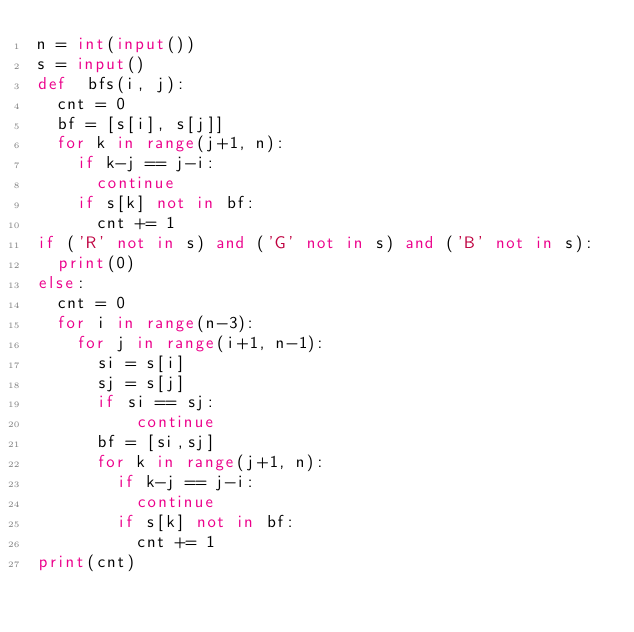Convert code to text. <code><loc_0><loc_0><loc_500><loc_500><_Python_>n = int(input())
s = input()
def  bfs(i, j):
  cnt = 0
  bf = [s[i], s[j]]
  for k in range(j+1, n):
    if k-j == j-i:
      continue
    if s[k] not in bf:
      cnt += 1
if ('R' not in s) and ('G' not in s) and ('B' not in s):
  print(0)
else:
  cnt = 0
  for i in range(n-3):
    for j in range(i+1, n-1):
      si = s[i]
      sj = s[j]
      if si == sj:
          continue
      bf = [si,sj]
      for k in range(j+1, n):
        if k-j == j-i:
          continue
        if s[k] not in bf:
          cnt += 1
print(cnt)</code> 